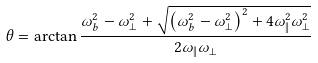<formula> <loc_0><loc_0><loc_500><loc_500>\theta = \arctan \frac { \omega _ { b } ^ { 2 } - \omega _ { \perp } ^ { 2 } + \sqrt { \left ( \omega _ { b } ^ { 2 } - \omega _ { \perp } ^ { 2 } \right ) ^ { 2 } + 4 \omega _ { \| } ^ { 2 } \omega _ { \perp } ^ { 2 } } } { 2 \omega _ { \| } \omega _ { \perp } }</formula> 